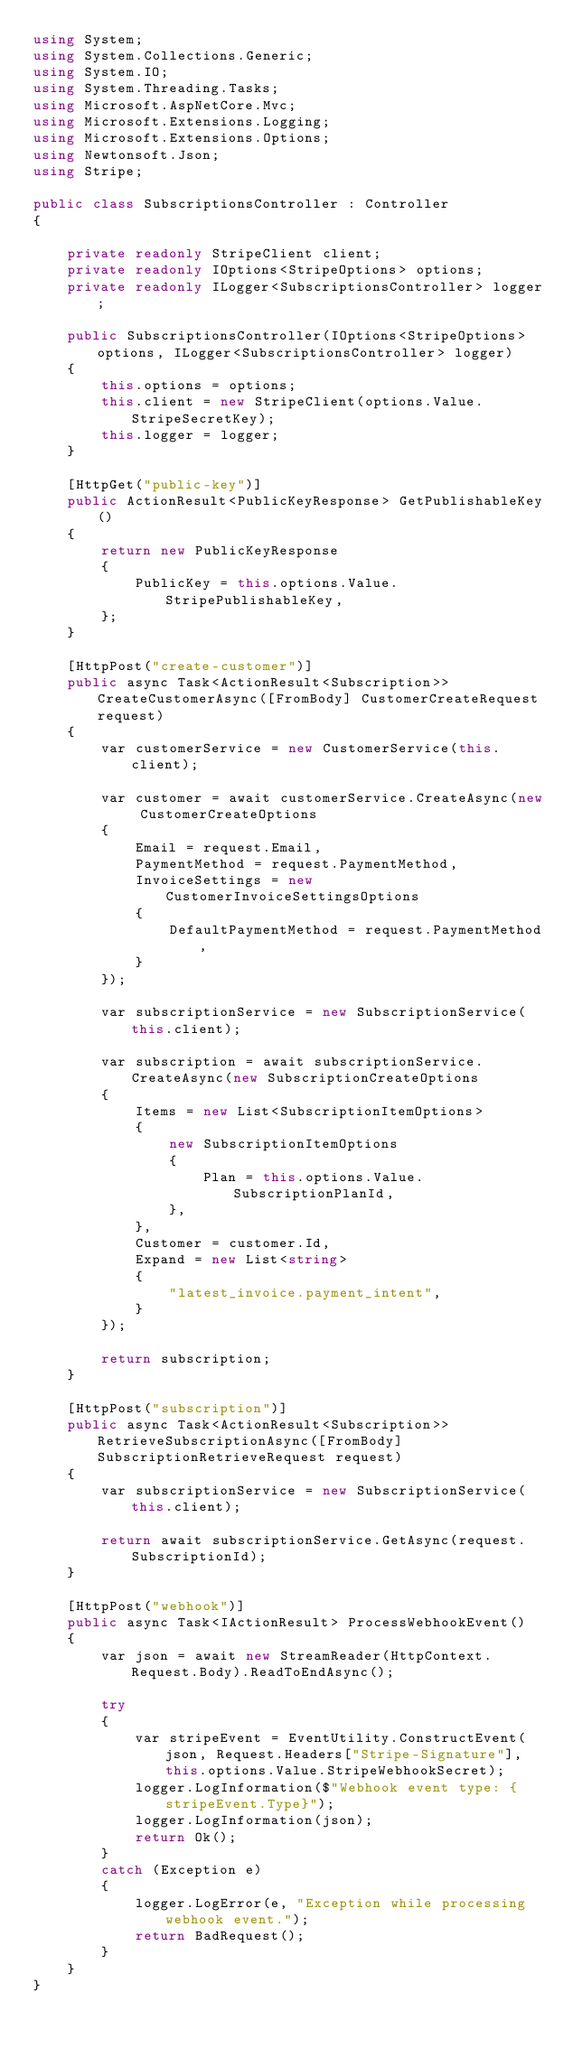<code> <loc_0><loc_0><loc_500><loc_500><_C#_>using System;
using System.Collections.Generic;
using System.IO;
using System.Threading.Tasks;
using Microsoft.AspNetCore.Mvc;
using Microsoft.Extensions.Logging;
using Microsoft.Extensions.Options;
using Newtonsoft.Json;
using Stripe;

public class SubscriptionsController : Controller
{

    private readonly StripeClient client;
    private readonly IOptions<StripeOptions> options;
    private readonly ILogger<SubscriptionsController> logger;

    public SubscriptionsController(IOptions<StripeOptions> options, ILogger<SubscriptionsController> logger)
    {
        this.options = options;
        this.client = new StripeClient(options.Value.StripeSecretKey);
        this.logger = logger;
    }

    [HttpGet("public-key")]
    public ActionResult<PublicKeyResponse> GetPublishableKey()
    {
        return new PublicKeyResponse
        {
            PublicKey = this.options.Value.StripePublishableKey,
        };
    }

    [HttpPost("create-customer")]
    public async Task<ActionResult<Subscription>> CreateCustomerAsync([FromBody] CustomerCreateRequest request)
    {
        var customerService = new CustomerService(this.client);

        var customer = await customerService.CreateAsync(new CustomerCreateOptions
        {
            Email = request.Email,
            PaymentMethod = request.PaymentMethod,
            InvoiceSettings = new CustomerInvoiceSettingsOptions
            {
                DefaultPaymentMethod = request.PaymentMethod,
            }
        });

        var subscriptionService = new SubscriptionService(this.client);

        var subscription = await subscriptionService.CreateAsync(new SubscriptionCreateOptions
        {
            Items = new List<SubscriptionItemOptions>
            {
                new SubscriptionItemOptions
                {
                    Plan = this.options.Value.SubscriptionPlanId,
                },
            },
            Customer = customer.Id,
            Expand = new List<string>
            {
                "latest_invoice.payment_intent",
            }
        });

        return subscription;
    }

    [HttpPost("subscription")]
    public async Task<ActionResult<Subscription>> RetrieveSubscriptionAsync([FromBody] SubscriptionRetrieveRequest request)
    {
        var subscriptionService = new SubscriptionService(this.client);

        return await subscriptionService.GetAsync(request.SubscriptionId);
    }

    [HttpPost("webhook")]
    public async Task<IActionResult> ProcessWebhookEvent()
    {
        var json = await new StreamReader(HttpContext.Request.Body).ReadToEndAsync();

        try
        {
            var stripeEvent = EventUtility.ConstructEvent(json, Request.Headers["Stripe-Signature"], this.options.Value.StripeWebhookSecret);
            logger.LogInformation($"Webhook event type: {stripeEvent.Type}");
            logger.LogInformation(json);
            return Ok();
        }
        catch (Exception e)
        {
            logger.LogError(e, "Exception while processing webhook event.");
            return BadRequest();
        }
    }
}</code> 